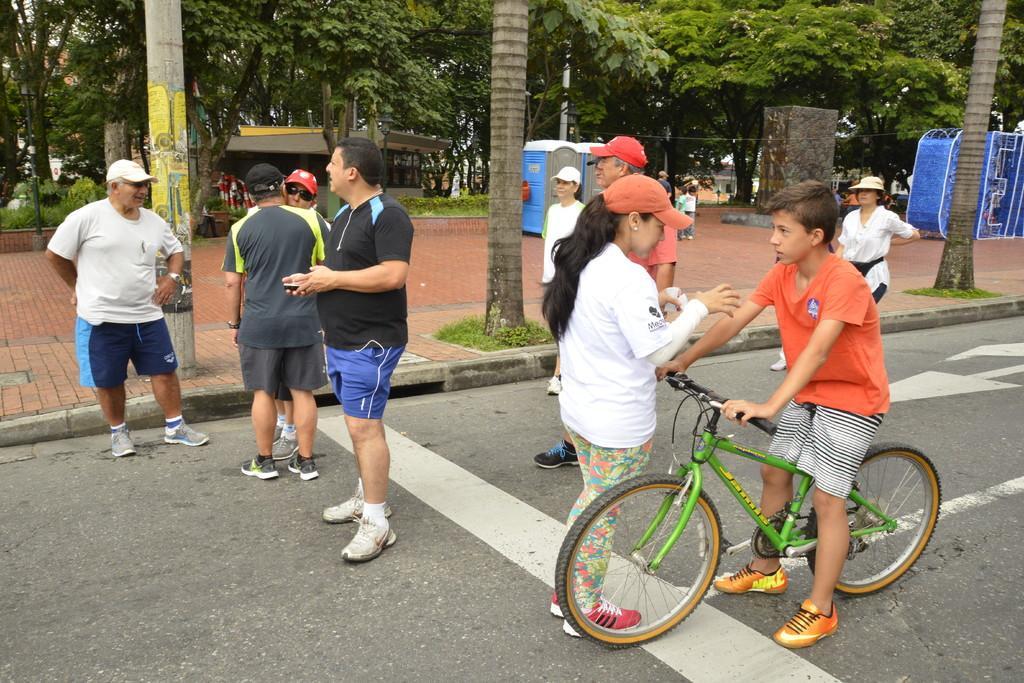Please provide a concise description of this image. In this image we can see a child sitting on the bicycle and few people are standing on the road. In the background we can see trees. 